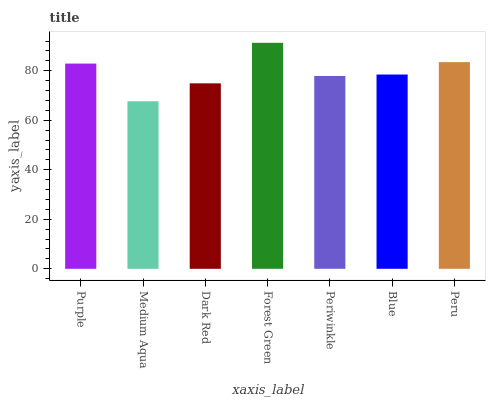Is Medium Aqua the minimum?
Answer yes or no. Yes. Is Forest Green the maximum?
Answer yes or no. Yes. Is Dark Red the minimum?
Answer yes or no. No. Is Dark Red the maximum?
Answer yes or no. No. Is Dark Red greater than Medium Aqua?
Answer yes or no. Yes. Is Medium Aqua less than Dark Red?
Answer yes or no. Yes. Is Medium Aqua greater than Dark Red?
Answer yes or no. No. Is Dark Red less than Medium Aqua?
Answer yes or no. No. Is Blue the high median?
Answer yes or no. Yes. Is Blue the low median?
Answer yes or no. Yes. Is Dark Red the high median?
Answer yes or no. No. Is Dark Red the low median?
Answer yes or no. No. 